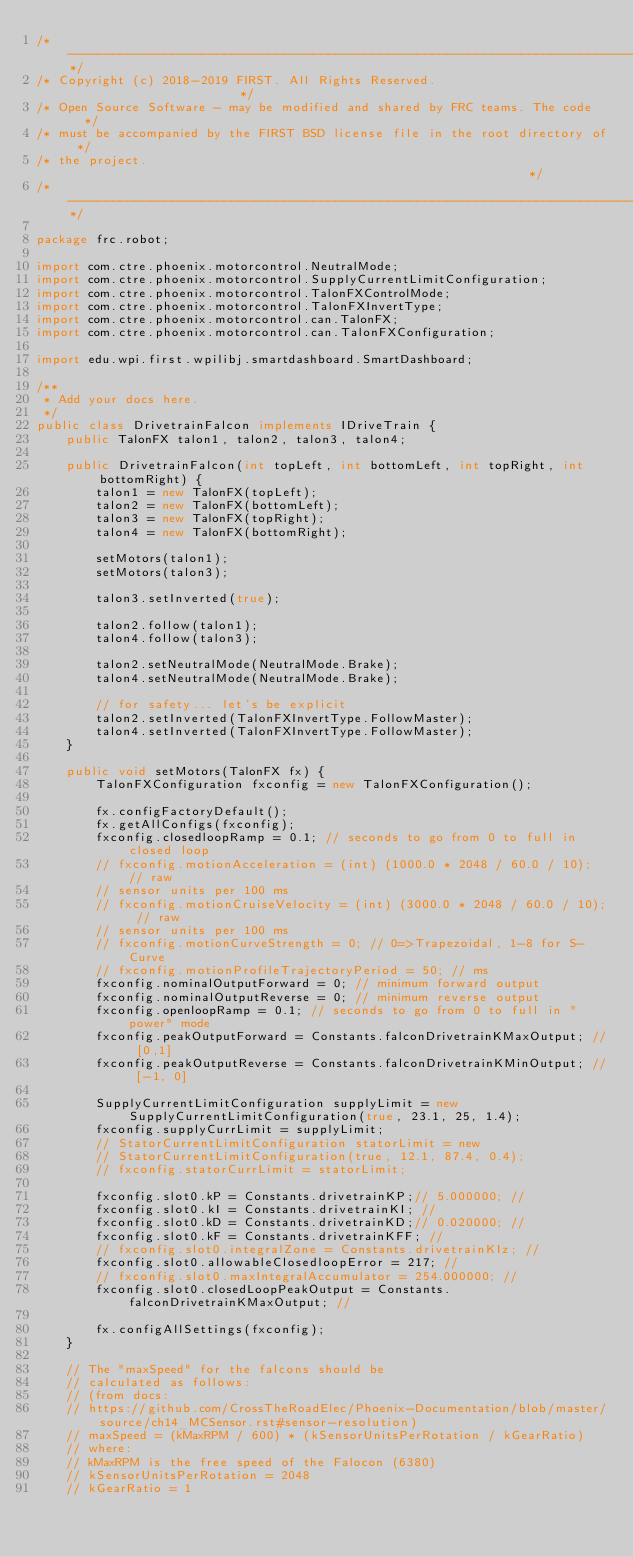<code> <loc_0><loc_0><loc_500><loc_500><_Java_>/*----------------------------------------------------------------------------*/
/* Copyright (c) 2018-2019 FIRST. All Rights Reserved.                        */
/* Open Source Software - may be modified and shared by FRC teams. The code   */
/* must be accompanied by the FIRST BSD license file in the root directory of */
/* the project.                                                               */
/*----------------------------------------------------------------------------*/

package frc.robot;

import com.ctre.phoenix.motorcontrol.NeutralMode;
import com.ctre.phoenix.motorcontrol.SupplyCurrentLimitConfiguration;
import com.ctre.phoenix.motorcontrol.TalonFXControlMode;
import com.ctre.phoenix.motorcontrol.TalonFXInvertType;
import com.ctre.phoenix.motorcontrol.can.TalonFX;
import com.ctre.phoenix.motorcontrol.can.TalonFXConfiguration;

import edu.wpi.first.wpilibj.smartdashboard.SmartDashboard;

/**
 * Add your docs here.
 */
public class DrivetrainFalcon implements IDriveTrain {
    public TalonFX talon1, talon2, talon3, talon4;

    public DrivetrainFalcon(int topLeft, int bottomLeft, int topRight, int bottomRight) {
        talon1 = new TalonFX(topLeft);
        talon2 = new TalonFX(bottomLeft);
        talon3 = new TalonFX(topRight);
        talon4 = new TalonFX(bottomRight);

        setMotors(talon1);
        setMotors(talon3);

        talon3.setInverted(true);

        talon2.follow(talon1);
        talon4.follow(talon3);

        talon2.setNeutralMode(NeutralMode.Brake);
        talon4.setNeutralMode(NeutralMode.Brake);

        // for safety... let's be explicit
        talon2.setInverted(TalonFXInvertType.FollowMaster);
        talon4.setInverted(TalonFXInvertType.FollowMaster);
    }

    public void setMotors(TalonFX fx) {
        TalonFXConfiguration fxconfig = new TalonFXConfiguration();

        fx.configFactoryDefault();
        fx.getAllConfigs(fxconfig);
        fxconfig.closedloopRamp = 0.1; // seconds to go from 0 to full in closed loop
        // fxconfig.motionAcceleration = (int) (1000.0 * 2048 / 60.0 / 10); // raw
        // sensor units per 100 ms
        // fxconfig.motionCruiseVelocity = (int) (3000.0 * 2048 / 60.0 / 10); // raw
        // sensor units per 100 ms
        // fxconfig.motionCurveStrength = 0; // 0=>Trapezoidal, 1-8 for S-Curve
        // fxconfig.motionProfileTrajectoryPeriod = 50; // ms
        fxconfig.nominalOutputForward = 0; // minimum forward output
        fxconfig.nominalOutputReverse = 0; // minimum reverse output
        fxconfig.openloopRamp = 0.1; // seconds to go from 0 to full in "power" mode
        fxconfig.peakOutputForward = Constants.falconDrivetrainKMaxOutput; // [0,1]
        fxconfig.peakOutputReverse = Constants.falconDrivetrainKMinOutput; // [-1, 0]

        SupplyCurrentLimitConfiguration supplyLimit = new SupplyCurrentLimitConfiguration(true, 23.1, 25, 1.4);
        fxconfig.supplyCurrLimit = supplyLimit;
        // StatorCurrentLimitConfiguration statorLimit = new
        // StatorCurrentLimitConfiguration(true, 12.1, 87.4, 0.4);
        // fxconfig.statorCurrLimit = statorLimit;

        fxconfig.slot0.kP = Constants.drivetrainKP;// 5.000000; //
        fxconfig.slot0.kI = Constants.drivetrainKI; //
        fxconfig.slot0.kD = Constants.drivetrainKD;// 0.020000; //
        fxconfig.slot0.kF = Constants.drivetrainKFF; //
        // fxconfig.slot0.integralZone = Constants.drivetrainKIz; //
        fxconfig.slot0.allowableClosedloopError = 217; //
        // fxconfig.slot0.maxIntegralAccumulator = 254.000000; //
        fxconfig.slot0.closedLoopPeakOutput = Constants.falconDrivetrainKMaxOutput; //

        fx.configAllSettings(fxconfig);
    }

    // The "maxSpeed" for the falcons should be
    // calculated as follows:
    // (from docs:
    // https://github.com/CrossTheRoadElec/Phoenix-Documentation/blob/master/source/ch14_MCSensor.rst#sensor-resolution)
    // maxSpeed = (kMaxRPM / 600) * (kSensorUnitsPerRotation / kGearRatio)
    // where:
    // kMaxRPM is the free speed of the Falocon (6380)
    // kSensorUnitsPerRotation = 2048
    // kGearRatio = 1</code> 